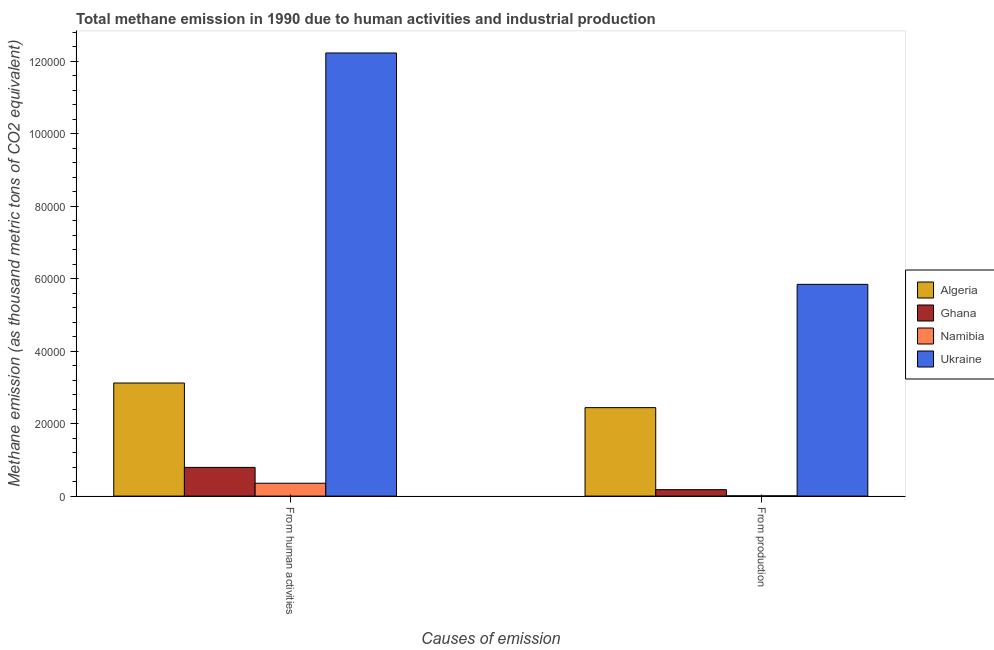How many different coloured bars are there?
Ensure brevity in your answer.  4. What is the label of the 1st group of bars from the left?
Provide a short and direct response. From human activities. What is the amount of emissions generated from industries in Namibia?
Offer a terse response. 77.6. Across all countries, what is the maximum amount of emissions from human activities?
Provide a short and direct response. 1.22e+05. Across all countries, what is the minimum amount of emissions generated from industries?
Offer a very short reply. 77.6. In which country was the amount of emissions from human activities maximum?
Provide a short and direct response. Ukraine. In which country was the amount of emissions generated from industries minimum?
Offer a terse response. Namibia. What is the total amount of emissions generated from industries in the graph?
Provide a short and direct response. 8.47e+04. What is the difference between the amount of emissions from human activities in Namibia and that in Ghana?
Keep it short and to the point. -4371.2. What is the difference between the amount of emissions from human activities in Namibia and the amount of emissions generated from industries in Ukraine?
Your answer should be compact. -5.49e+04. What is the average amount of emissions from human activities per country?
Give a very brief answer. 4.12e+04. What is the difference between the amount of emissions generated from industries and amount of emissions from human activities in Algeria?
Provide a succinct answer. -6797.8. What is the ratio of the amount of emissions from human activities in Algeria to that in Namibia?
Keep it short and to the point. 8.78. Is the amount of emissions generated from industries in Algeria less than that in Ukraine?
Make the answer very short. Yes. In how many countries, is the amount of emissions from human activities greater than the average amount of emissions from human activities taken over all countries?
Your answer should be compact. 1. What does the 1st bar from the left in From human activities represents?
Make the answer very short. Algeria. What does the 1st bar from the right in From production represents?
Your answer should be compact. Ukraine. How many bars are there?
Offer a terse response. 8. Are all the bars in the graph horizontal?
Your answer should be compact. No. What is the difference between two consecutive major ticks on the Y-axis?
Give a very brief answer. 2.00e+04. Are the values on the major ticks of Y-axis written in scientific E-notation?
Give a very brief answer. No. Does the graph contain any zero values?
Make the answer very short. No. How many legend labels are there?
Your answer should be compact. 4. What is the title of the graph?
Keep it short and to the point. Total methane emission in 1990 due to human activities and industrial production. What is the label or title of the X-axis?
Offer a terse response. Causes of emission. What is the label or title of the Y-axis?
Provide a succinct answer. Methane emission (as thousand metric tons of CO2 equivalent). What is the Methane emission (as thousand metric tons of CO2 equivalent) in Algeria in From human activities?
Give a very brief answer. 3.12e+04. What is the Methane emission (as thousand metric tons of CO2 equivalent) of Ghana in From human activities?
Ensure brevity in your answer.  7924.7. What is the Methane emission (as thousand metric tons of CO2 equivalent) of Namibia in From human activities?
Your response must be concise. 3553.5. What is the Methane emission (as thousand metric tons of CO2 equivalent) of Ukraine in From human activities?
Ensure brevity in your answer.  1.22e+05. What is the Methane emission (as thousand metric tons of CO2 equivalent) in Algeria in From production?
Offer a terse response. 2.44e+04. What is the Methane emission (as thousand metric tons of CO2 equivalent) of Ghana in From production?
Offer a very short reply. 1784.9. What is the Methane emission (as thousand metric tons of CO2 equivalent) in Namibia in From production?
Offer a terse response. 77.6. What is the Methane emission (as thousand metric tons of CO2 equivalent) of Ukraine in From production?
Provide a short and direct response. 5.84e+04. Across all Causes of emission, what is the maximum Methane emission (as thousand metric tons of CO2 equivalent) in Algeria?
Give a very brief answer. 3.12e+04. Across all Causes of emission, what is the maximum Methane emission (as thousand metric tons of CO2 equivalent) of Ghana?
Offer a very short reply. 7924.7. Across all Causes of emission, what is the maximum Methane emission (as thousand metric tons of CO2 equivalent) in Namibia?
Provide a succinct answer. 3553.5. Across all Causes of emission, what is the maximum Methane emission (as thousand metric tons of CO2 equivalent) of Ukraine?
Your answer should be very brief. 1.22e+05. Across all Causes of emission, what is the minimum Methane emission (as thousand metric tons of CO2 equivalent) in Algeria?
Give a very brief answer. 2.44e+04. Across all Causes of emission, what is the minimum Methane emission (as thousand metric tons of CO2 equivalent) of Ghana?
Make the answer very short. 1784.9. Across all Causes of emission, what is the minimum Methane emission (as thousand metric tons of CO2 equivalent) of Namibia?
Ensure brevity in your answer.  77.6. Across all Causes of emission, what is the minimum Methane emission (as thousand metric tons of CO2 equivalent) in Ukraine?
Your answer should be compact. 5.84e+04. What is the total Methane emission (as thousand metric tons of CO2 equivalent) of Algeria in the graph?
Give a very brief answer. 5.56e+04. What is the total Methane emission (as thousand metric tons of CO2 equivalent) in Ghana in the graph?
Keep it short and to the point. 9709.6. What is the total Methane emission (as thousand metric tons of CO2 equivalent) in Namibia in the graph?
Keep it short and to the point. 3631.1. What is the total Methane emission (as thousand metric tons of CO2 equivalent) in Ukraine in the graph?
Your response must be concise. 1.81e+05. What is the difference between the Methane emission (as thousand metric tons of CO2 equivalent) of Algeria in From human activities and that in From production?
Your response must be concise. 6797.8. What is the difference between the Methane emission (as thousand metric tons of CO2 equivalent) in Ghana in From human activities and that in From production?
Keep it short and to the point. 6139.8. What is the difference between the Methane emission (as thousand metric tons of CO2 equivalent) in Namibia in From human activities and that in From production?
Ensure brevity in your answer.  3475.9. What is the difference between the Methane emission (as thousand metric tons of CO2 equivalent) in Ukraine in From human activities and that in From production?
Provide a succinct answer. 6.38e+04. What is the difference between the Methane emission (as thousand metric tons of CO2 equivalent) of Algeria in From human activities and the Methane emission (as thousand metric tons of CO2 equivalent) of Ghana in From production?
Give a very brief answer. 2.94e+04. What is the difference between the Methane emission (as thousand metric tons of CO2 equivalent) of Algeria in From human activities and the Methane emission (as thousand metric tons of CO2 equivalent) of Namibia in From production?
Your answer should be very brief. 3.11e+04. What is the difference between the Methane emission (as thousand metric tons of CO2 equivalent) in Algeria in From human activities and the Methane emission (as thousand metric tons of CO2 equivalent) in Ukraine in From production?
Offer a terse response. -2.72e+04. What is the difference between the Methane emission (as thousand metric tons of CO2 equivalent) in Ghana in From human activities and the Methane emission (as thousand metric tons of CO2 equivalent) in Namibia in From production?
Your response must be concise. 7847.1. What is the difference between the Methane emission (as thousand metric tons of CO2 equivalent) of Ghana in From human activities and the Methane emission (as thousand metric tons of CO2 equivalent) of Ukraine in From production?
Your answer should be compact. -5.05e+04. What is the difference between the Methane emission (as thousand metric tons of CO2 equivalent) of Namibia in From human activities and the Methane emission (as thousand metric tons of CO2 equivalent) of Ukraine in From production?
Offer a very short reply. -5.49e+04. What is the average Methane emission (as thousand metric tons of CO2 equivalent) of Algeria per Causes of emission?
Keep it short and to the point. 2.78e+04. What is the average Methane emission (as thousand metric tons of CO2 equivalent) in Ghana per Causes of emission?
Provide a short and direct response. 4854.8. What is the average Methane emission (as thousand metric tons of CO2 equivalent) in Namibia per Causes of emission?
Your response must be concise. 1815.55. What is the average Methane emission (as thousand metric tons of CO2 equivalent) of Ukraine per Causes of emission?
Give a very brief answer. 9.04e+04. What is the difference between the Methane emission (as thousand metric tons of CO2 equivalent) in Algeria and Methane emission (as thousand metric tons of CO2 equivalent) in Ghana in From human activities?
Offer a very short reply. 2.33e+04. What is the difference between the Methane emission (as thousand metric tons of CO2 equivalent) of Algeria and Methane emission (as thousand metric tons of CO2 equivalent) of Namibia in From human activities?
Offer a very short reply. 2.77e+04. What is the difference between the Methane emission (as thousand metric tons of CO2 equivalent) of Algeria and Methane emission (as thousand metric tons of CO2 equivalent) of Ukraine in From human activities?
Provide a succinct answer. -9.11e+04. What is the difference between the Methane emission (as thousand metric tons of CO2 equivalent) of Ghana and Methane emission (as thousand metric tons of CO2 equivalent) of Namibia in From human activities?
Provide a succinct answer. 4371.2. What is the difference between the Methane emission (as thousand metric tons of CO2 equivalent) in Ghana and Methane emission (as thousand metric tons of CO2 equivalent) in Ukraine in From human activities?
Ensure brevity in your answer.  -1.14e+05. What is the difference between the Methane emission (as thousand metric tons of CO2 equivalent) in Namibia and Methane emission (as thousand metric tons of CO2 equivalent) in Ukraine in From human activities?
Your response must be concise. -1.19e+05. What is the difference between the Methane emission (as thousand metric tons of CO2 equivalent) in Algeria and Methane emission (as thousand metric tons of CO2 equivalent) in Ghana in From production?
Give a very brief answer. 2.26e+04. What is the difference between the Methane emission (as thousand metric tons of CO2 equivalent) in Algeria and Methane emission (as thousand metric tons of CO2 equivalent) in Namibia in From production?
Offer a very short reply. 2.43e+04. What is the difference between the Methane emission (as thousand metric tons of CO2 equivalent) of Algeria and Methane emission (as thousand metric tons of CO2 equivalent) of Ukraine in From production?
Give a very brief answer. -3.40e+04. What is the difference between the Methane emission (as thousand metric tons of CO2 equivalent) of Ghana and Methane emission (as thousand metric tons of CO2 equivalent) of Namibia in From production?
Your response must be concise. 1707.3. What is the difference between the Methane emission (as thousand metric tons of CO2 equivalent) of Ghana and Methane emission (as thousand metric tons of CO2 equivalent) of Ukraine in From production?
Provide a succinct answer. -5.66e+04. What is the difference between the Methane emission (as thousand metric tons of CO2 equivalent) in Namibia and Methane emission (as thousand metric tons of CO2 equivalent) in Ukraine in From production?
Your answer should be very brief. -5.84e+04. What is the ratio of the Methane emission (as thousand metric tons of CO2 equivalent) in Algeria in From human activities to that in From production?
Your response must be concise. 1.28. What is the ratio of the Methane emission (as thousand metric tons of CO2 equivalent) of Ghana in From human activities to that in From production?
Your answer should be very brief. 4.44. What is the ratio of the Methane emission (as thousand metric tons of CO2 equivalent) of Namibia in From human activities to that in From production?
Provide a succinct answer. 45.79. What is the ratio of the Methane emission (as thousand metric tons of CO2 equivalent) of Ukraine in From human activities to that in From production?
Provide a succinct answer. 2.09. What is the difference between the highest and the second highest Methane emission (as thousand metric tons of CO2 equivalent) of Algeria?
Your answer should be very brief. 6797.8. What is the difference between the highest and the second highest Methane emission (as thousand metric tons of CO2 equivalent) of Ghana?
Your answer should be very brief. 6139.8. What is the difference between the highest and the second highest Methane emission (as thousand metric tons of CO2 equivalent) of Namibia?
Provide a succinct answer. 3475.9. What is the difference between the highest and the second highest Methane emission (as thousand metric tons of CO2 equivalent) in Ukraine?
Provide a succinct answer. 6.38e+04. What is the difference between the highest and the lowest Methane emission (as thousand metric tons of CO2 equivalent) of Algeria?
Ensure brevity in your answer.  6797.8. What is the difference between the highest and the lowest Methane emission (as thousand metric tons of CO2 equivalent) in Ghana?
Your answer should be compact. 6139.8. What is the difference between the highest and the lowest Methane emission (as thousand metric tons of CO2 equivalent) of Namibia?
Your answer should be very brief. 3475.9. What is the difference between the highest and the lowest Methane emission (as thousand metric tons of CO2 equivalent) of Ukraine?
Your response must be concise. 6.38e+04. 